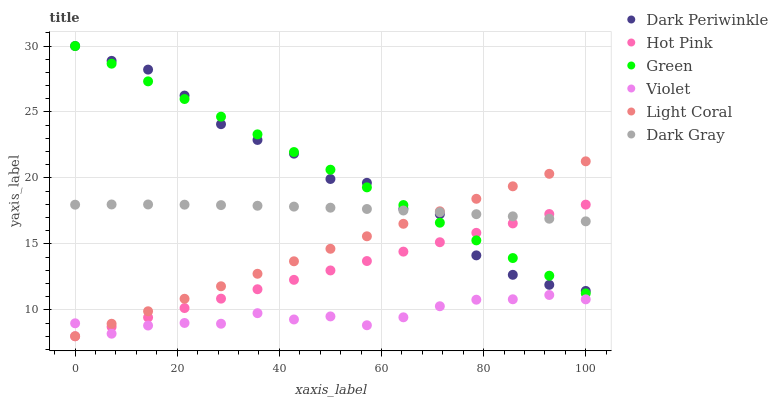Does Violet have the minimum area under the curve?
Answer yes or no. Yes. Does Green have the maximum area under the curve?
Answer yes or no. Yes. Does Hot Pink have the minimum area under the curve?
Answer yes or no. No. Does Hot Pink have the maximum area under the curve?
Answer yes or no. No. Is Light Coral the smoothest?
Answer yes or no. Yes. Is Dark Periwinkle the roughest?
Answer yes or no. Yes. Is Hot Pink the smoothest?
Answer yes or no. No. Is Hot Pink the roughest?
Answer yes or no. No. Does Hot Pink have the lowest value?
Answer yes or no. Yes. Does Green have the lowest value?
Answer yes or no. No. Does Dark Periwinkle have the highest value?
Answer yes or no. Yes. Does Hot Pink have the highest value?
Answer yes or no. No. Is Violet less than Dark Periwinkle?
Answer yes or no. Yes. Is Dark Gray greater than Violet?
Answer yes or no. Yes. Does Dark Gray intersect Hot Pink?
Answer yes or no. Yes. Is Dark Gray less than Hot Pink?
Answer yes or no. No. Is Dark Gray greater than Hot Pink?
Answer yes or no. No. Does Violet intersect Dark Periwinkle?
Answer yes or no. No. 